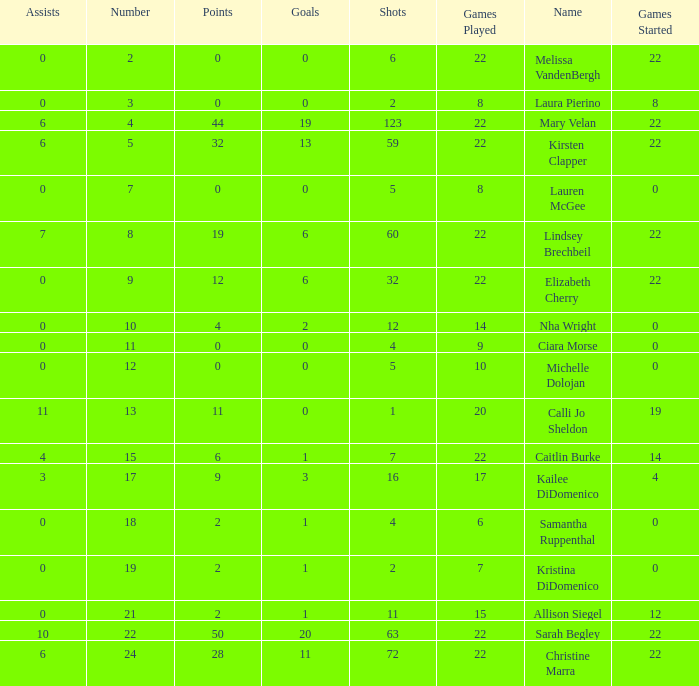How many names are listed for the player with 50 points? 1.0. 